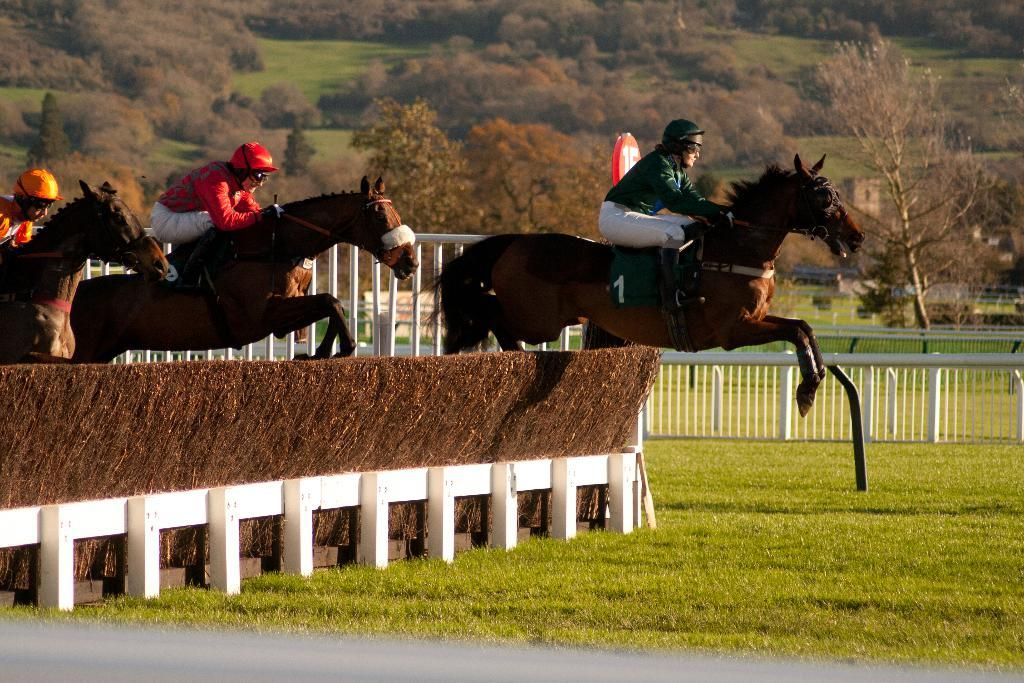What are the people in the image doing? The people in the image are riding horses. What can be seen in the background of the image? There are trees and a fence in the background of the image. What type of ring can be seen on the horse's neck in the image? There is no ring visible on any horse's neck in the image. 